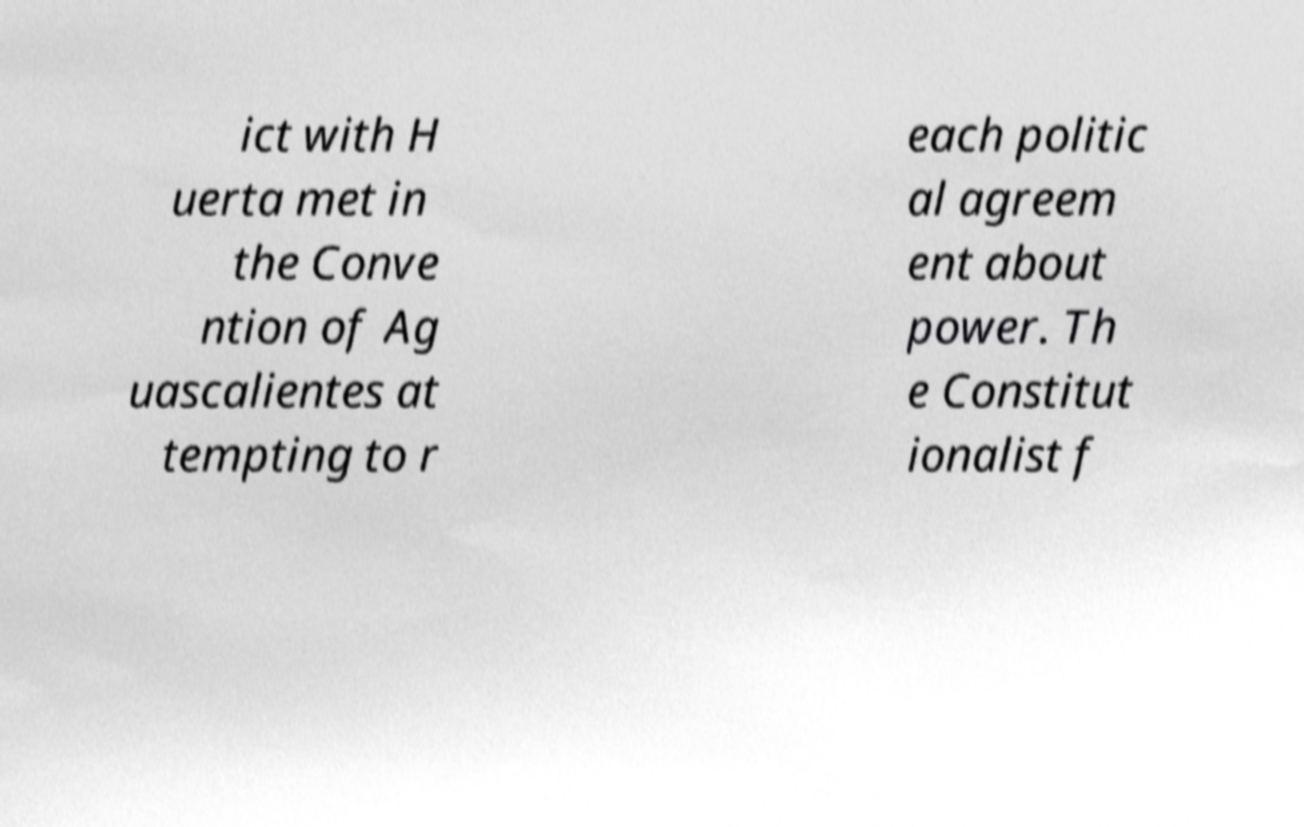What messages or text are displayed in this image? I need them in a readable, typed format. ict with H uerta met in the Conve ntion of Ag uascalientes at tempting to r each politic al agreem ent about power. Th e Constitut ionalist f 